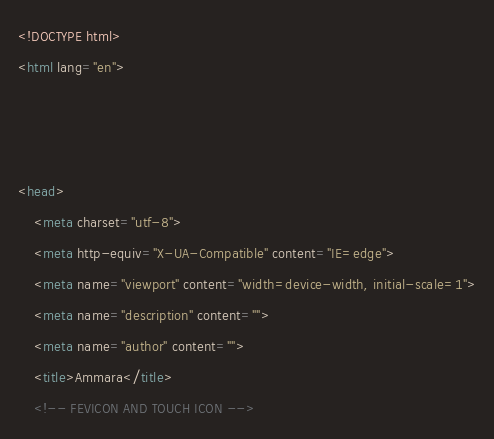<code> <loc_0><loc_0><loc_500><loc_500><_HTML_><!DOCTYPE html>
<html lang="en">



<head>
    <meta charset="utf-8">
    <meta http-equiv="X-UA-Compatible" content="IE=edge">
    <meta name="viewport" content="width=device-width, initial-scale=1">
    <meta name="description" content="">
    <meta name="author" content="">
    <title>Ammara</title>
    <!-- FEVICON AND TOUCH ICON --></code> 